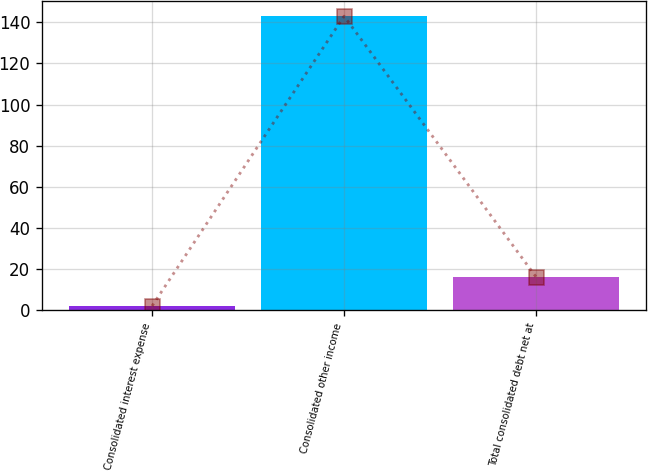Convert chart. <chart><loc_0><loc_0><loc_500><loc_500><bar_chart><fcel>Consolidated interest expense<fcel>Consolidated other income<fcel>Total consolidated debt net at<nl><fcel>2<fcel>143<fcel>16.1<nl></chart> 